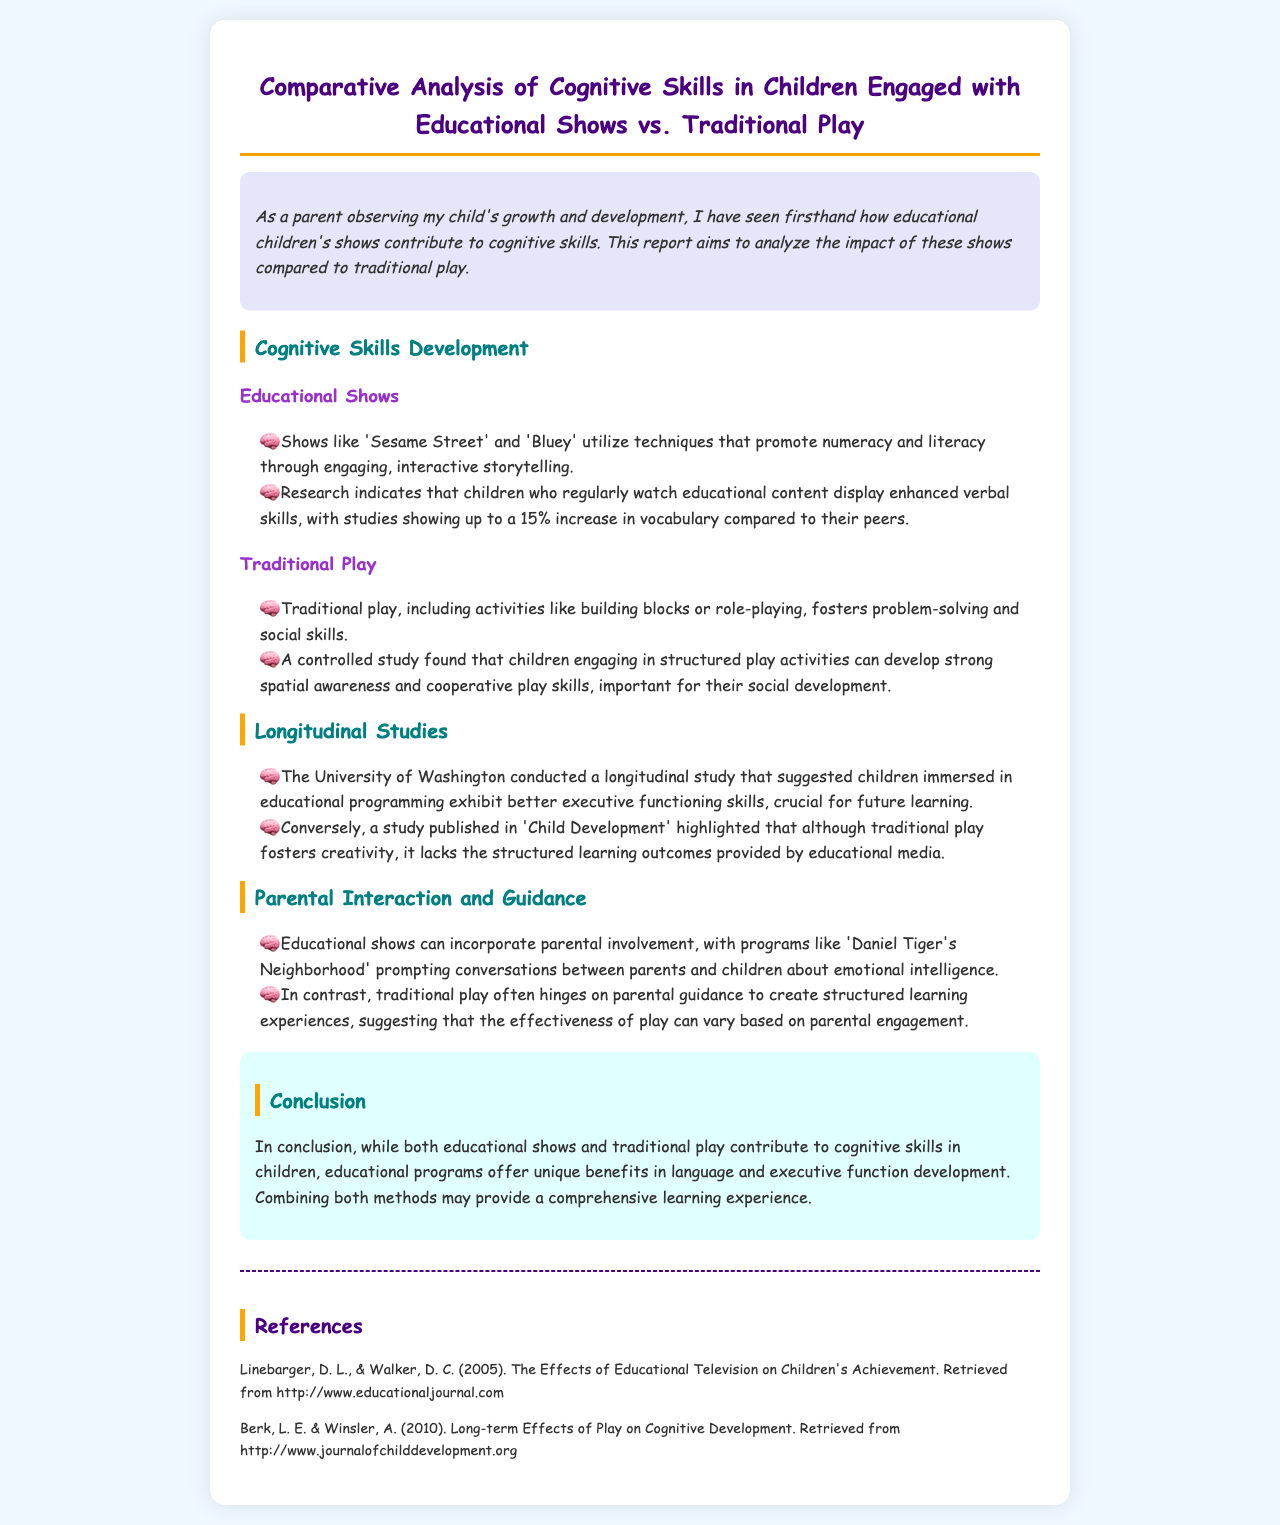what is the title of the report? The title of the report is clearly stated at the beginning of the document.
Answer: Comparative Analysis of Cognitive Skills in Children Engaged with Educational Shows vs. Traditional Play which educational show is mentioned as an example for literacy promotion? The document provides specific examples of educational shows that promote literacy.
Answer: Sesame Street what percentage increase in vocabulary was noted for children watching educational content? The report cites a research finding regarding vocabulary improvement among children who watch educational shows.
Answer: 15% which institution conducted a longitudinal study on educational programming? The report specifies the institution responsible for the longitudinal study regarding educational programming.
Answer: University of Washington what unique benefit do educational programs offer according to the conclusion? The conclusion emphasizes a specific cognitive development area where educational programs excel.
Answer: language what role do educational shows play in parental interaction according to the document? The report discusses how educational shows facilitate a certain type of interaction between parents and children.
Answer: Emotional intelligence what type of play fosters problem-solving according to the document? The report mentions the category of play that helps in developing specific skills.
Answer: Traditional play what is suggested for optimal cognitive skills development in children? The conclusion offers a recommendation for enhancing cognitive skill development in children.
Answer: Combining both methods 